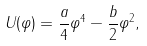Convert formula to latex. <formula><loc_0><loc_0><loc_500><loc_500>U ( \varphi ) = \frac { a } { 4 } \varphi ^ { 4 } - \frac { b } { 2 } \varphi ^ { 2 } ,</formula> 